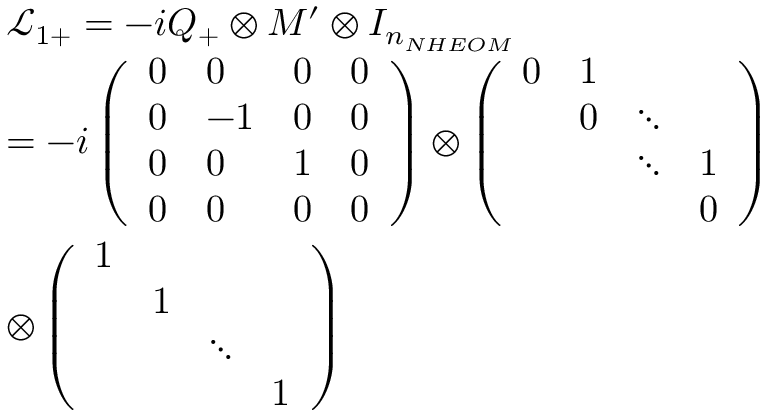Convert formula to latex. <formula><loc_0><loc_0><loc_500><loc_500>\begin{array} { r l } & { { \mathcal { L } _ { 1 + } } = - i Q _ { + } \otimes M ^ { \prime } \otimes { { I } _ { { { n } _ { N H E O M } } } } } \\ & { = - i \left ( \begin{array} { l l l l } { 0 } & { 0 } & { 0 } & { 0 } \\ { 0 } & { - 1 } & { 0 } & { 0 } \\ { 0 } & { 0 } & { 1 } & { 0 } \\ { 0 } & { 0 } & { 0 } & { 0 } \end{array} \right ) \otimes \left ( \begin{array} { l l l l } { 0 } & { 1 } & { 0 } & { \ddots } & { \ddots } & { 1 } & { 0 } \end{array} \right ) } \\ & { \otimes \left ( \begin{array} { l l l l } { 1 } & { 1 } & { \ddots } & { 1 } \end{array} \right ) } \end{array}</formula> 